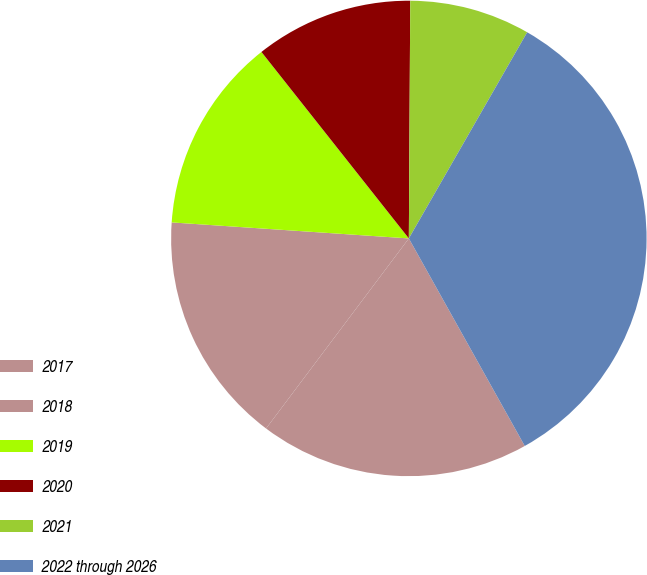Convert chart. <chart><loc_0><loc_0><loc_500><loc_500><pie_chart><fcel>2017<fcel>2018<fcel>2019<fcel>2020<fcel>2021<fcel>2022 through 2026<nl><fcel>18.36%<fcel>15.82%<fcel>13.28%<fcel>10.74%<fcel>8.2%<fcel>33.6%<nl></chart> 